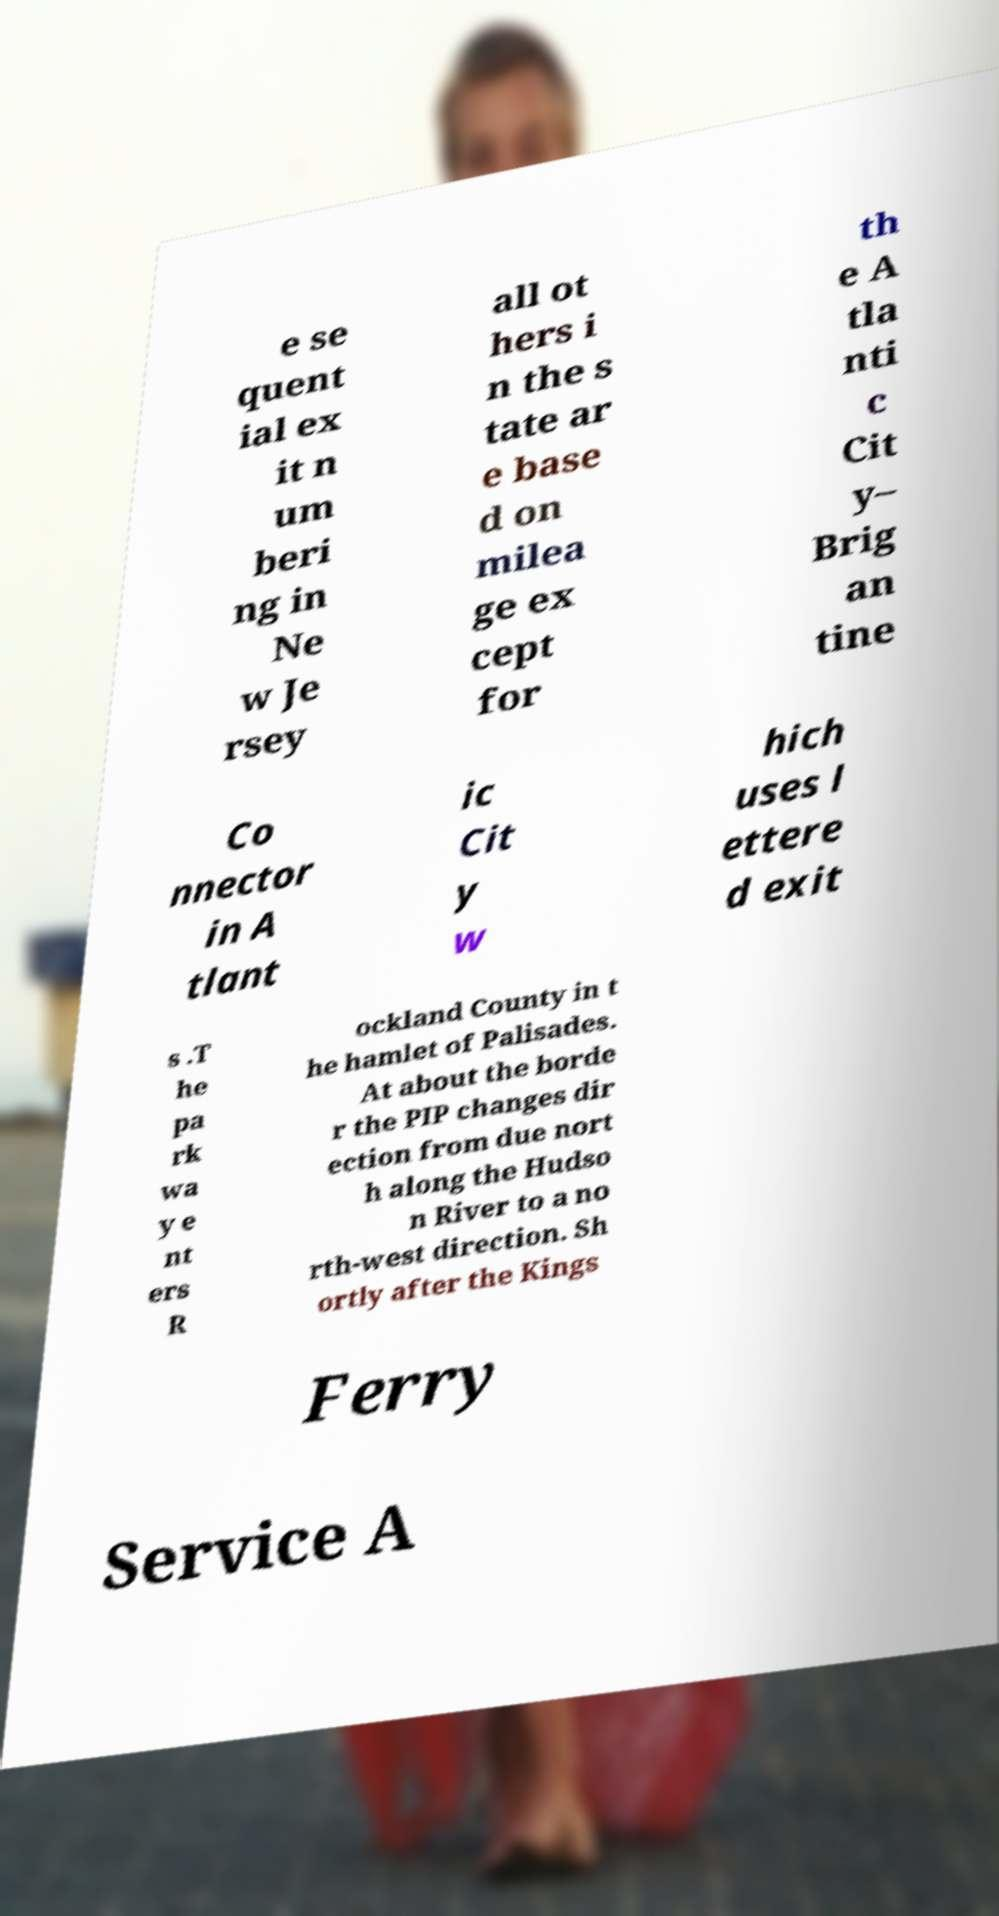I need the written content from this picture converted into text. Can you do that? e se quent ial ex it n um beri ng in Ne w Je rsey all ot hers i n the s tate ar e base d on milea ge ex cept for th e A tla nti c Cit y– Brig an tine Co nnector in A tlant ic Cit y w hich uses l ettere d exit s .T he pa rk wa y e nt ers R ockland County in t he hamlet of Palisades. At about the borde r the PIP changes dir ection from due nort h along the Hudso n River to a no rth-west direction. Sh ortly after the Kings Ferry Service A 